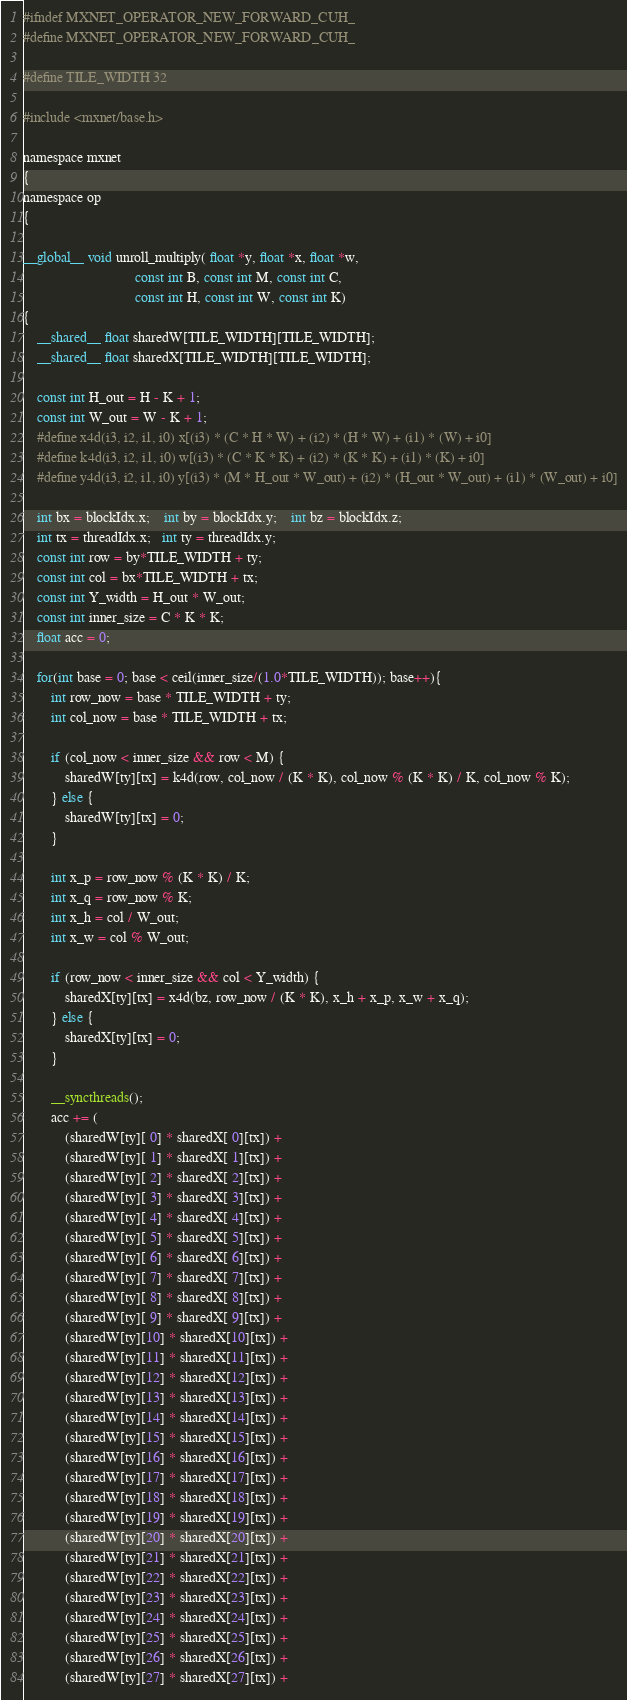Convert code to text. <code><loc_0><loc_0><loc_500><loc_500><_Cuda_>#ifndef MXNET_OPERATOR_NEW_FORWARD_CUH_
#define MXNET_OPERATOR_NEW_FORWARD_CUH_

#define TILE_WIDTH 32

#include <mxnet/base.h>

namespace mxnet
{
namespace op
{

__global__ void unroll_multiply( float *y, float *x, float *w,
                                const int B, const int M, const int C,
                                const int H, const int W, const int K)
{
    __shared__ float sharedW[TILE_WIDTH][TILE_WIDTH];
    __shared__ float sharedX[TILE_WIDTH][TILE_WIDTH];

    const int H_out = H - K + 1;
    const int W_out = W - K + 1;
    #define x4d(i3, i2, i1, i0) x[(i3) * (C * H * W) + (i2) * (H * W) + (i1) * (W) + i0]
    #define k4d(i3, i2, i1, i0) w[(i3) * (C * K * K) + (i2) * (K * K) + (i1) * (K) + i0]
    #define y4d(i3, i2, i1, i0) y[(i3) * (M * H_out * W_out) + (i2) * (H_out * W_out) + (i1) * (W_out) + i0]

    int bx = blockIdx.x;    int by = blockIdx.y;    int bz = blockIdx.z;
    int tx = threadIdx.x;   int ty = threadIdx.y;
    const int row = by*TILE_WIDTH + ty;
    const int col = bx*TILE_WIDTH + tx;
    const int Y_width = H_out * W_out;
    const int inner_size = C * K * K;
    float acc = 0;

    for(int base = 0; base < ceil(inner_size/(1.0*TILE_WIDTH)); base++){
        int row_now = base * TILE_WIDTH + ty;
        int col_now = base * TILE_WIDTH + tx;

        if (col_now < inner_size && row < M) {
            sharedW[ty][tx] = k4d(row, col_now / (K * K), col_now % (K * K) / K, col_now % K);
        } else {
            sharedW[ty][tx] = 0;
        }

        int x_p = row_now % (K * K) / K;
        int x_q = row_now % K;
        int x_h = col / W_out;
        int x_w = col % W_out;

        if (row_now < inner_size && col < Y_width) {
            sharedX[ty][tx] = x4d(bz, row_now / (K * K), x_h + x_p, x_w + x_q);
        } else {
            sharedX[ty][tx] = 0;
        }

        __syncthreads();
        acc += (
            (sharedW[ty][ 0] * sharedX[ 0][tx]) +
            (sharedW[ty][ 1] * sharedX[ 1][tx]) +
            (sharedW[ty][ 2] * sharedX[ 2][tx]) +
            (sharedW[ty][ 3] * sharedX[ 3][tx]) +
            (sharedW[ty][ 4] * sharedX[ 4][tx]) +
            (sharedW[ty][ 5] * sharedX[ 5][tx]) +
            (sharedW[ty][ 6] * sharedX[ 6][tx]) +
            (sharedW[ty][ 7] * sharedX[ 7][tx]) +
            (sharedW[ty][ 8] * sharedX[ 8][tx]) +
            (sharedW[ty][ 9] * sharedX[ 9][tx]) +
            (sharedW[ty][10] * sharedX[10][tx]) +
            (sharedW[ty][11] * sharedX[11][tx]) +
            (sharedW[ty][12] * sharedX[12][tx]) +
            (sharedW[ty][13] * sharedX[13][tx]) +
            (sharedW[ty][14] * sharedX[14][tx]) +
            (sharedW[ty][15] * sharedX[15][tx]) +
            (sharedW[ty][16] * sharedX[16][tx]) +
            (sharedW[ty][17] * sharedX[17][tx]) +
            (sharedW[ty][18] * sharedX[18][tx]) +
            (sharedW[ty][19] * sharedX[19][tx]) +
            (sharedW[ty][20] * sharedX[20][tx]) +
            (sharedW[ty][21] * sharedX[21][tx]) +
            (sharedW[ty][22] * sharedX[22][tx]) +
            (sharedW[ty][23] * sharedX[23][tx]) +
            (sharedW[ty][24] * sharedX[24][tx]) +
            (sharedW[ty][25] * sharedX[25][tx]) +
            (sharedW[ty][26] * sharedX[26][tx]) +
            (sharedW[ty][27] * sharedX[27][tx]) +</code> 